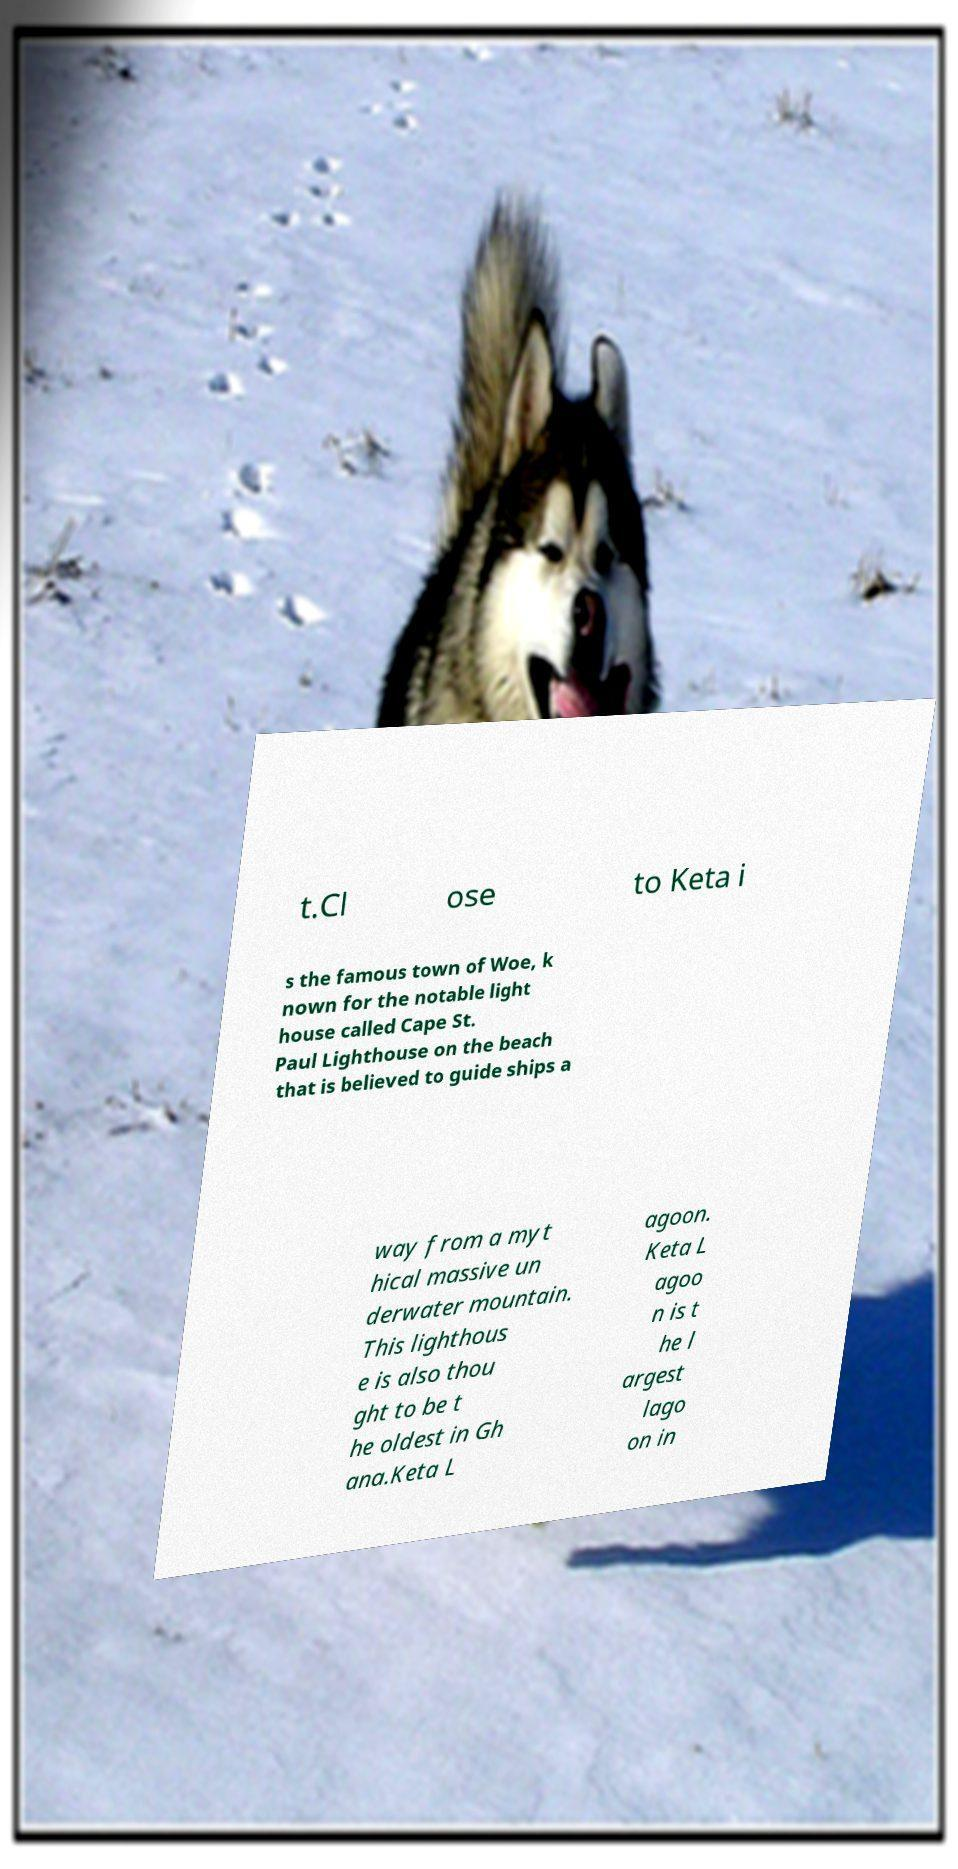I need the written content from this picture converted into text. Can you do that? t.Cl ose to Keta i s the famous town of Woe, k nown for the notable light house called Cape St. Paul Lighthouse on the beach that is believed to guide ships a way from a myt hical massive un derwater mountain. This lighthous e is also thou ght to be t he oldest in Gh ana.Keta L agoon. Keta L agoo n is t he l argest lago on in 